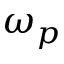Convert formula to latex. <formula><loc_0><loc_0><loc_500><loc_500>\omega _ { p }</formula> 